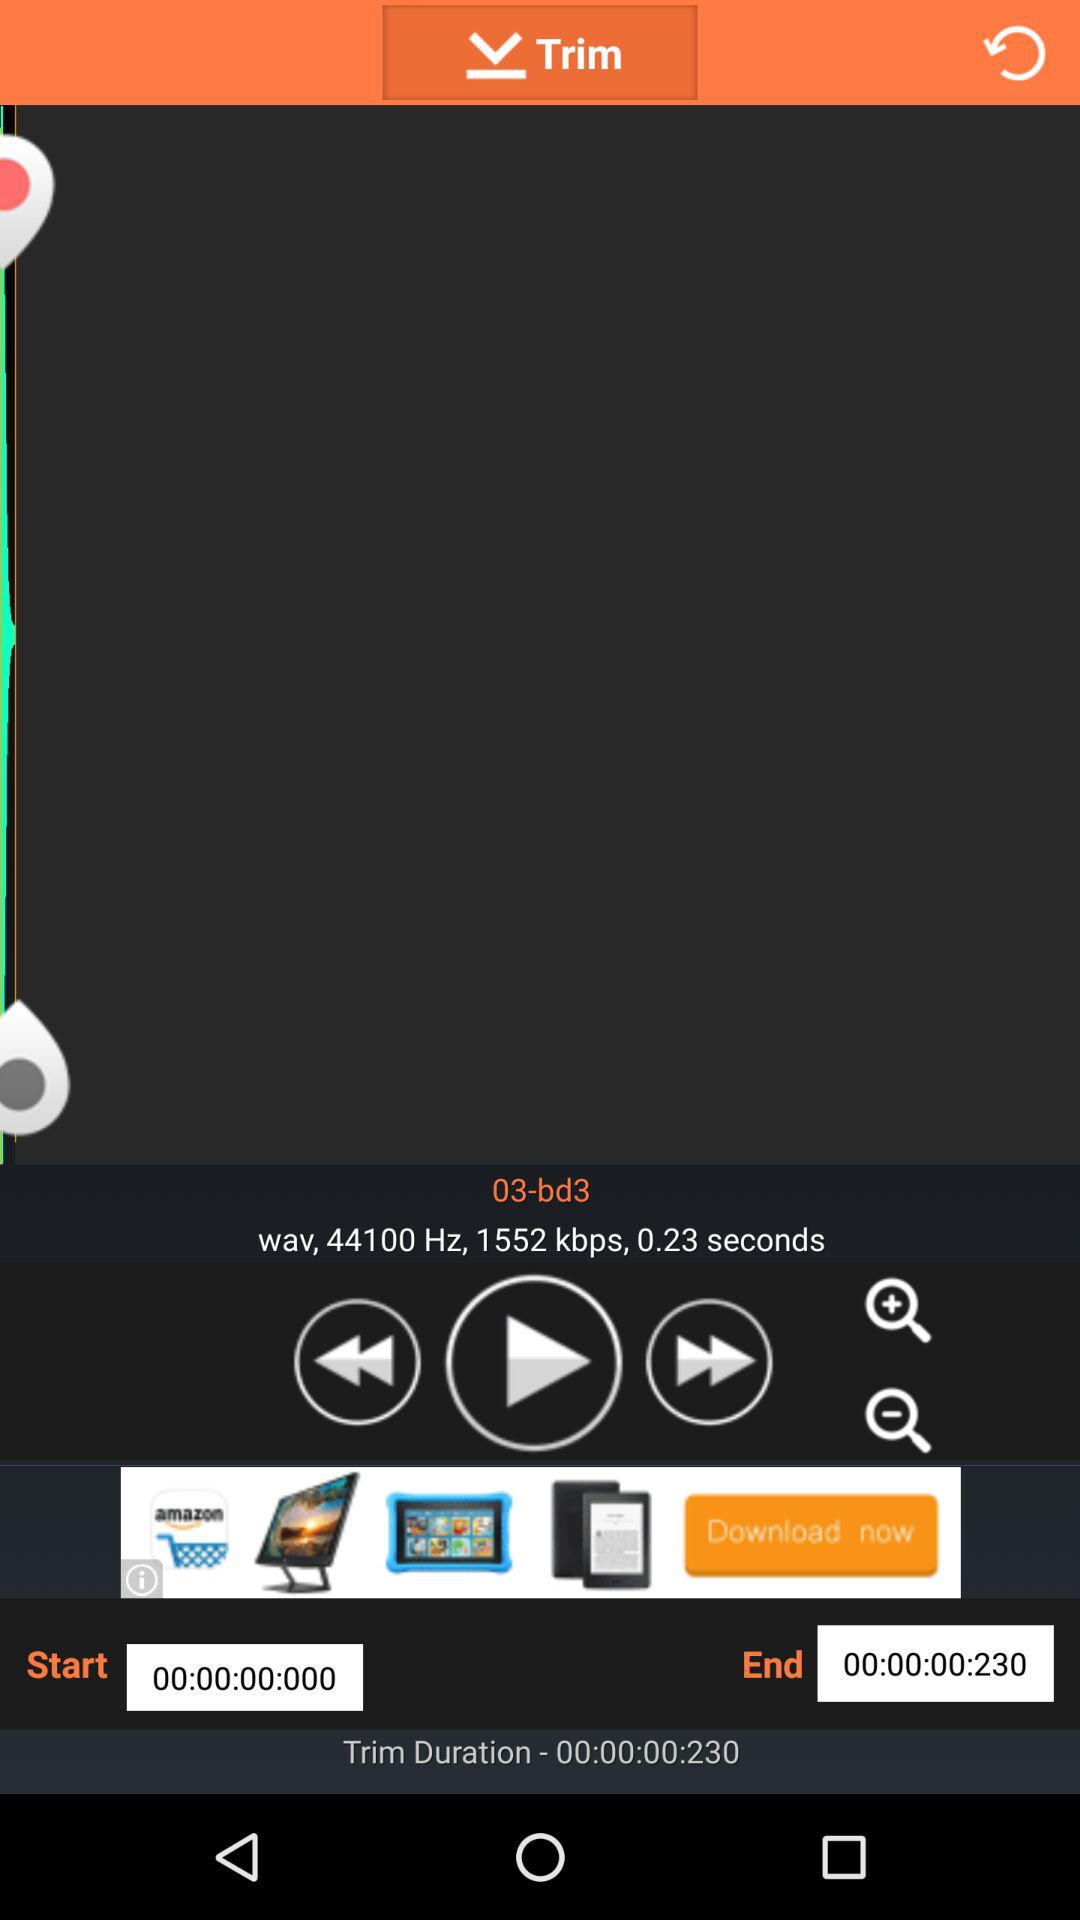What's the name of the song? The name of the song is "03-bd3". 